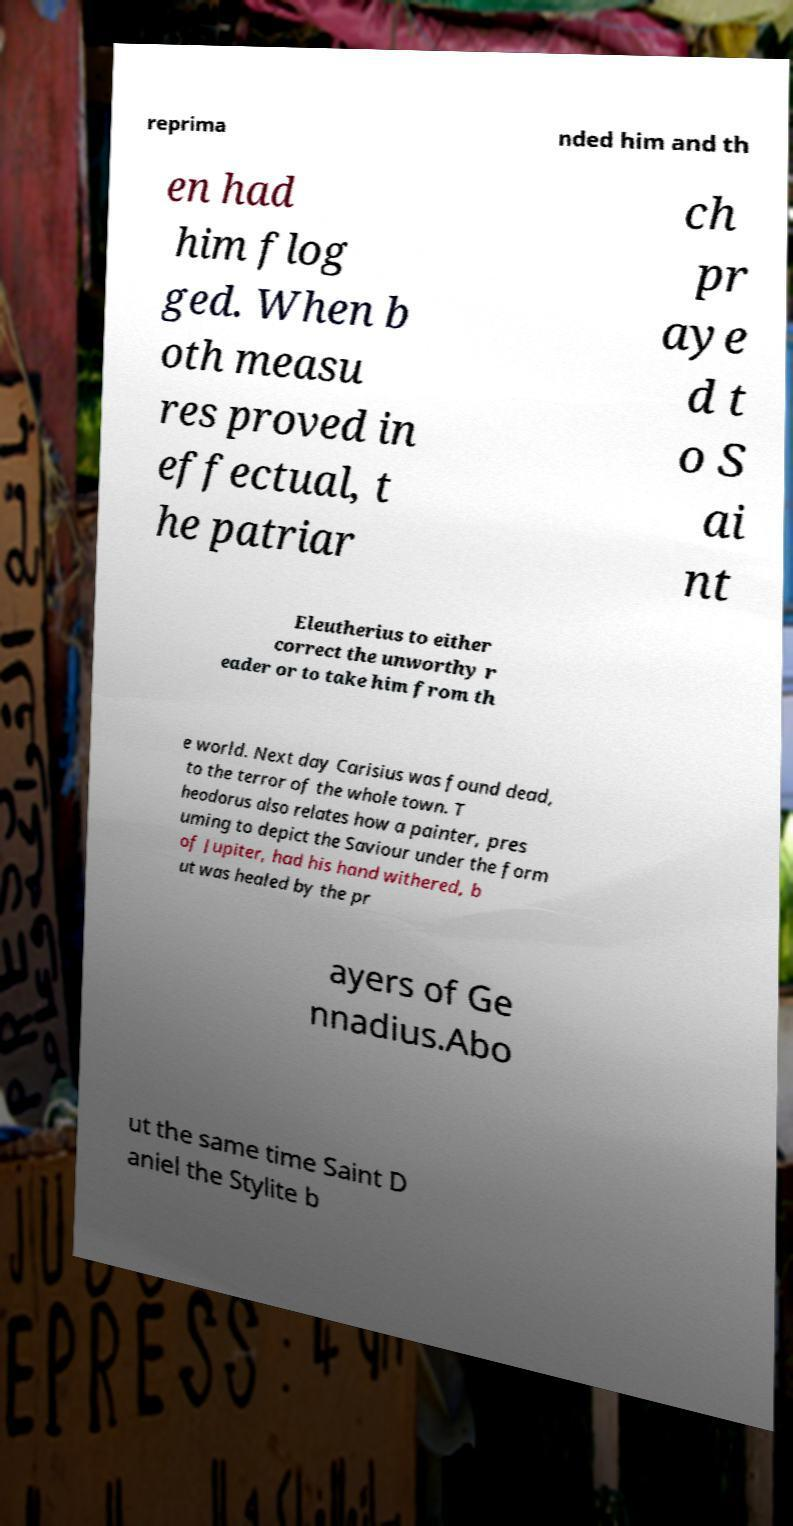Please identify and transcribe the text found in this image. reprima nded him and th en had him flog ged. When b oth measu res proved in effectual, t he patriar ch pr aye d t o S ai nt Eleutherius to either correct the unworthy r eader or to take him from th e world. Next day Carisius was found dead, to the terror of the whole town. T heodorus also relates how a painter, pres uming to depict the Saviour under the form of Jupiter, had his hand withered, b ut was healed by the pr ayers of Ge nnadius.Abo ut the same time Saint D aniel the Stylite b 